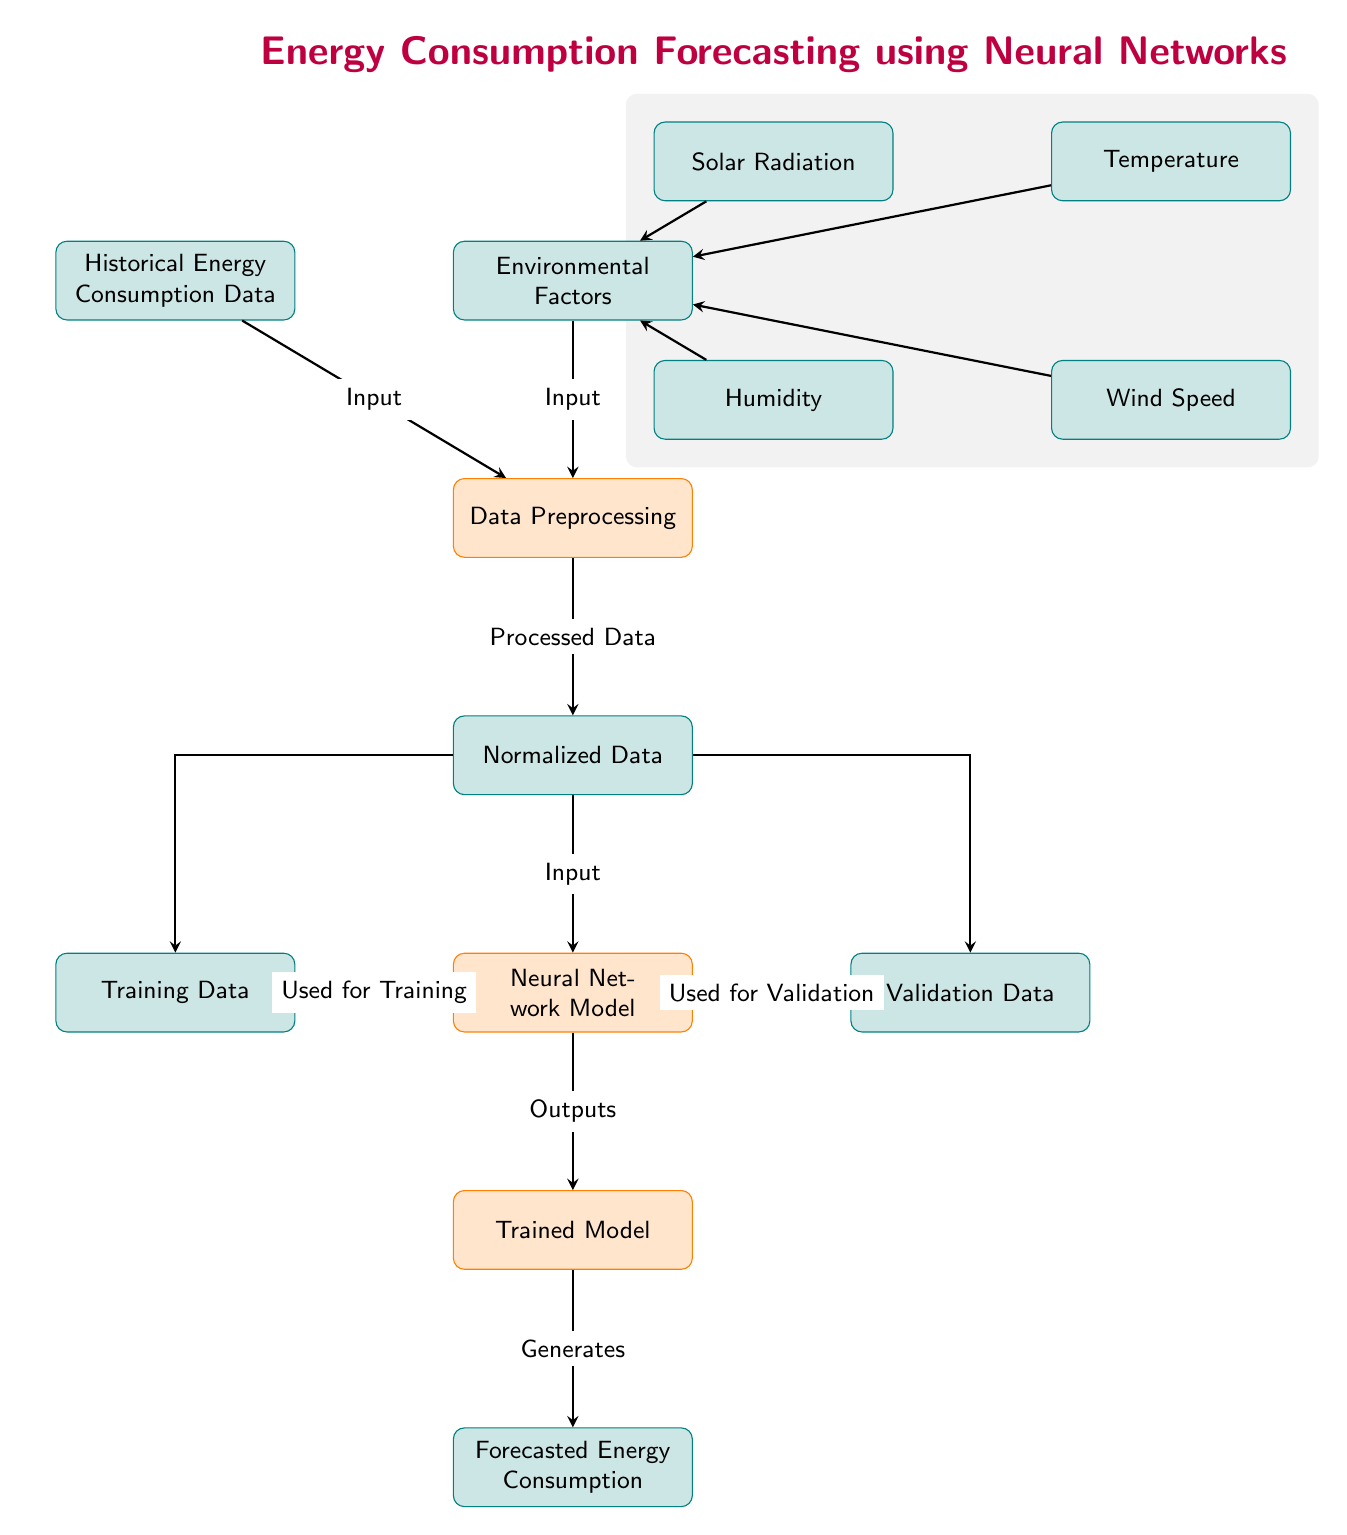What are the two main types of input data in this diagram? The diagram identifies two main types of input data: 'Historical Energy Consumption Data' and 'Environmental Factors.' These are presented as data nodes at the top of the diagram.
Answer: Historical Energy Consumption Data and Environmental Factors How many environmental factors are listed in the diagram? The diagram shows four environmental factors: Solar Radiation, Temperature, Humidity, and Wind Speed. They are nodes branching out from the Environmental Factors node.
Answer: Four What is the purpose of the 'Data Preprocessing' node? The 'Data Preprocessing' node serves as a step between input data and the neural network model, where it transforms raw data into a suitable format for training. It connects the input from both Historical Energy Consumption Data and Environmental Factors.
Answer: Transforming raw data What happens to the normalized data in the process? The normalized data goes to the Neural Network Model, which uses it for training and validation. Therefore, after preprocessing, the normalized data becomes the input for the neural network processes.
Answer: Becomes input for neural network Which node follows directly after the 'Trained Model' node? The node that directly follows the 'Trained Model' node is 'Forecasted Energy Consumption.' This indicates the output of the training process from the neural network is the forecasted energy consumption.
Answer: Forecasted Energy Consumption How does the training data connect to the neural network model? The training data connects to the neural network model directly, serving as one of the inputs for training. The arrow indicates this flow from the training data to the NN node.
Answer: Directly through an arrow What type of data is produced by the 'Neural Network Model'? The output produced by the 'Neural Network Model' is labeled as 'Trained Model,' indicating that after processing the training and validation data, the model produces a trained version of itself.
Answer: Trained Model What kind of processing does the diagram imply takes place with input data before forecasting? The diagram implies that the input data undergoes 'Data Preprocessing' to prepare the data, which includes normalization, before it is fed into the neural network for further predictions.
Answer: Data Preprocessing What is the last step in the flow of the diagram? The last step in the flow of the diagram is the generation of 'Forecasted Energy Consumption,' which is the final output of the system after processing through the neural network.
Answer: Forecasted Energy Consumption 